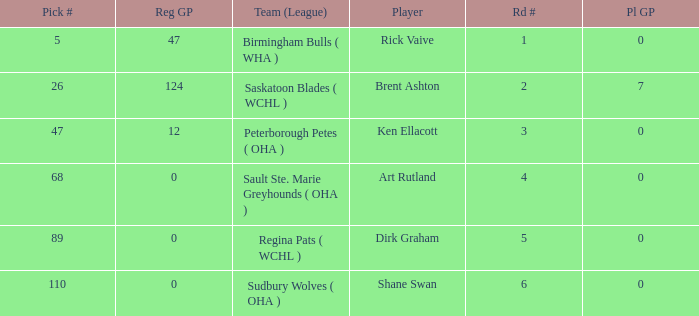How many reg GP for rick vaive in round 1? None. 